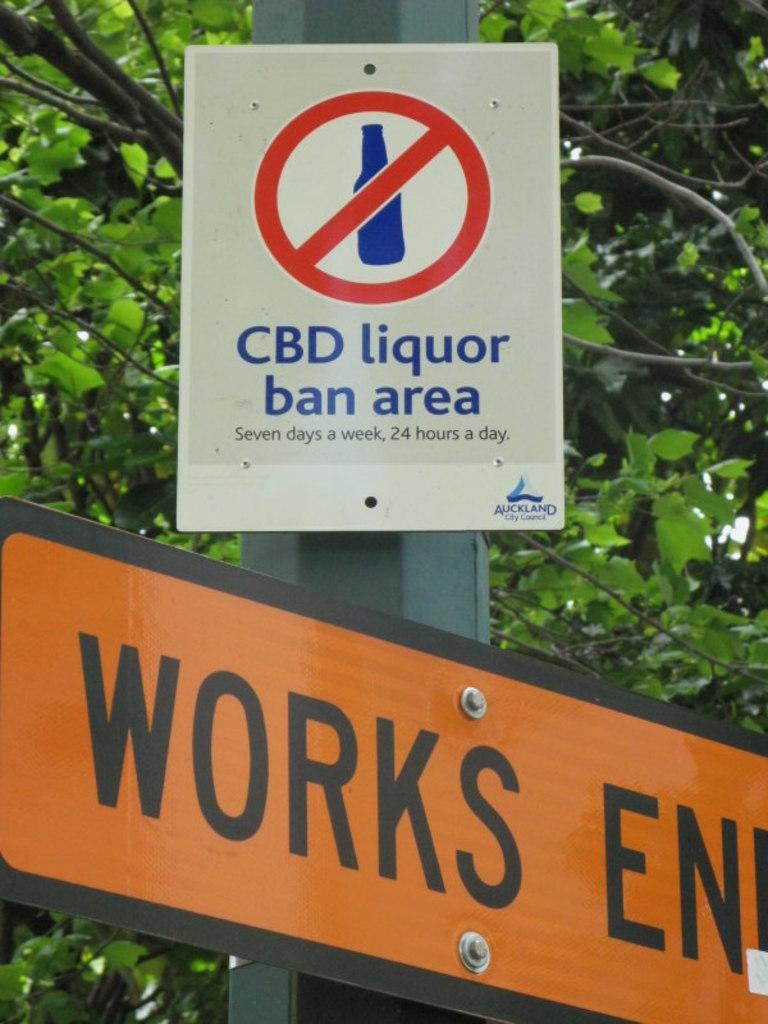Provide a one-sentence caption for the provided image. The street sign lets you know that you cannot have CBD liquor in the area. 